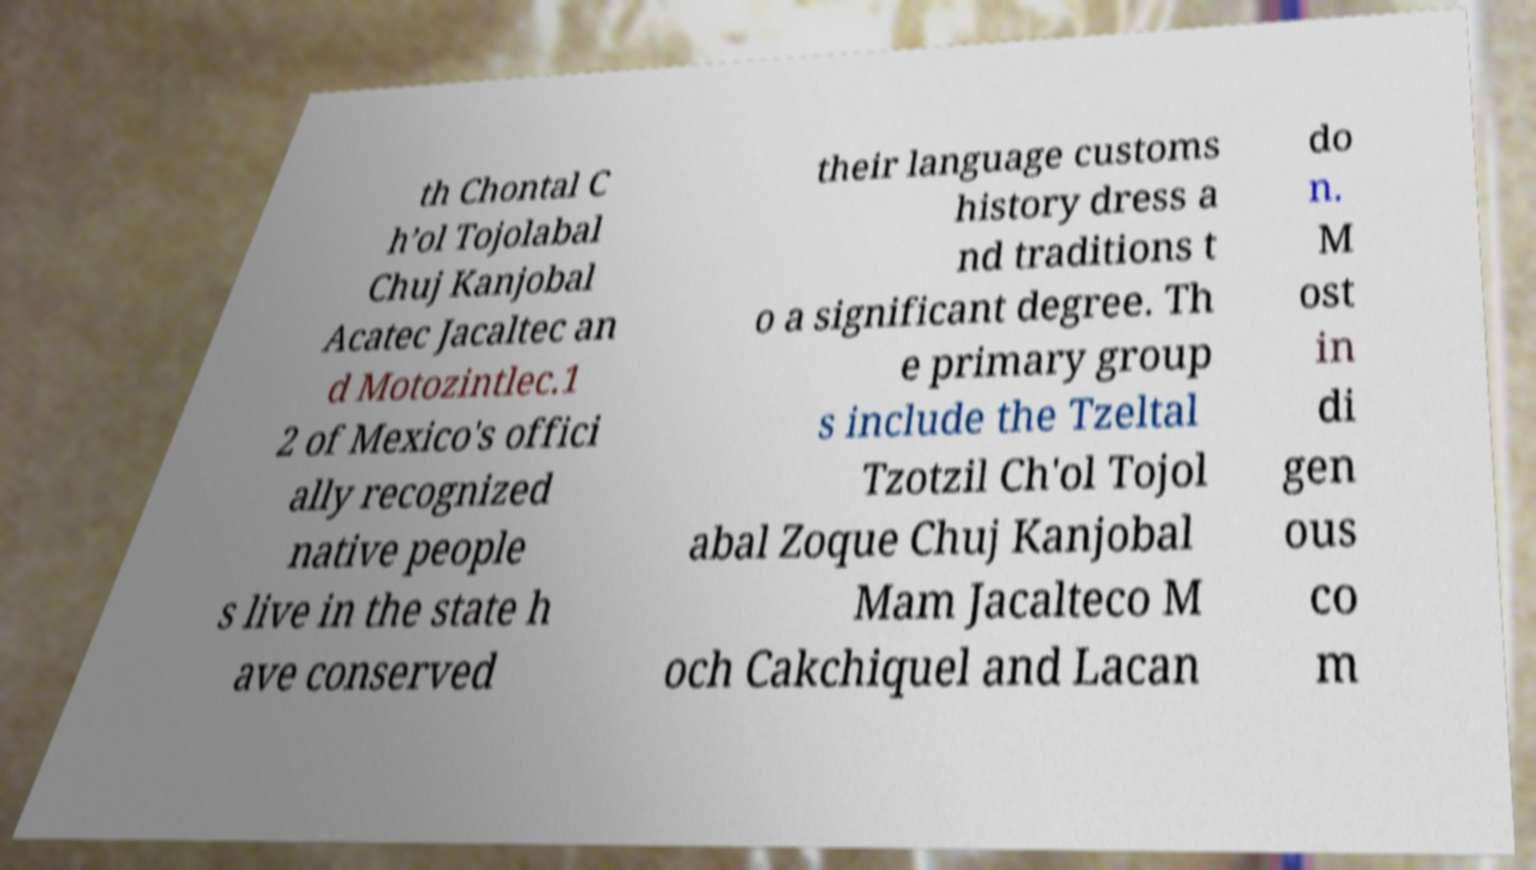There's text embedded in this image that I need extracted. Can you transcribe it verbatim? th Chontal C h’ol Tojolabal Chuj Kanjobal Acatec Jacaltec an d Motozintlec.1 2 of Mexico's offici ally recognized native people s live in the state h ave conserved their language customs history dress a nd traditions t o a significant degree. Th e primary group s include the Tzeltal Tzotzil Ch'ol Tojol abal Zoque Chuj Kanjobal Mam Jacalteco M och Cakchiquel and Lacan do n. M ost in di gen ous co m 